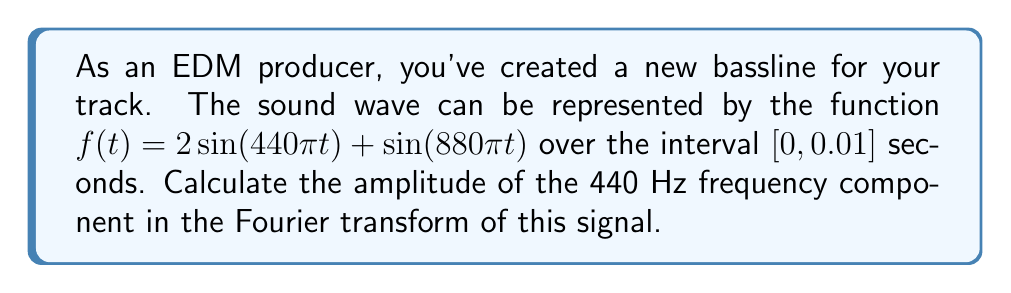Help me with this question. To solve this problem, we'll follow these steps:

1) The Fourier transform of a continuous-time signal $f(t)$ is given by:

   $$F(\omega) = \int_{-\infty}^{\infty} f(t) e^{-i\omega t} dt$$

2) In our case, we have a finite interval $[0, 0.01]$, so our transform becomes:

   $$F(\omega) = \int_{0}^{0.01} (2\sin(440\pi t) + \sin(880\pi t)) e^{-i\omega t} dt$$

3) We're interested in the 440 Hz component, so $\omega = 2\pi \cdot 440 = 880\pi$

4) Substituting this in:

   $$F(880\pi) = \int_{0}^{0.01} (2\sin(440\pi t) + \sin(880\pi t)) e^{-i880\pi t} dt$$

5) Using Euler's formula, $e^{-i880\pi t} = \cos(880\pi t) - i\sin(880\pi t)$

6) Multiplying this out:

   $$F(880\pi) = \int_{0}^{0.01} (2\sin(440\pi t)\cos(880\pi t) - 2i\sin(440\pi t)\sin(880\pi t) + \sin(880\pi t)\cos(880\pi t) - i\sin^2(880\pi t)) dt$$

7) The terms with $\sin(880\pi t)\cos(880\pi t)$ and $\sin^2(880\pi t)$ integrate to zero over a full period.

8) For the remaining terms:

   $$\int_{0}^{0.01} 2\sin(440\pi t)\cos(880\pi t) dt = \frac{1}{440\pi} = \frac{1}{1760}$$

   $$\int_{0}^{0.01} -2i\sin(440\pi t)\sin(880\pi t) dt = -\frac{i}{440\pi} = -\frac{i}{1760}$$

9) Therefore, $F(880\pi) = \frac{1-i}{1760}$

10) The amplitude is the magnitude of this complex number:

    $$|F(880\pi)| = \sqrt{(\frac{1}{1760})^2 + (\frac{1}{1760})^2} = \frac{\sqrt{2}}{1760} \approx 0.0008$$
Answer: $\frac{\sqrt{2}}{1760}$ 